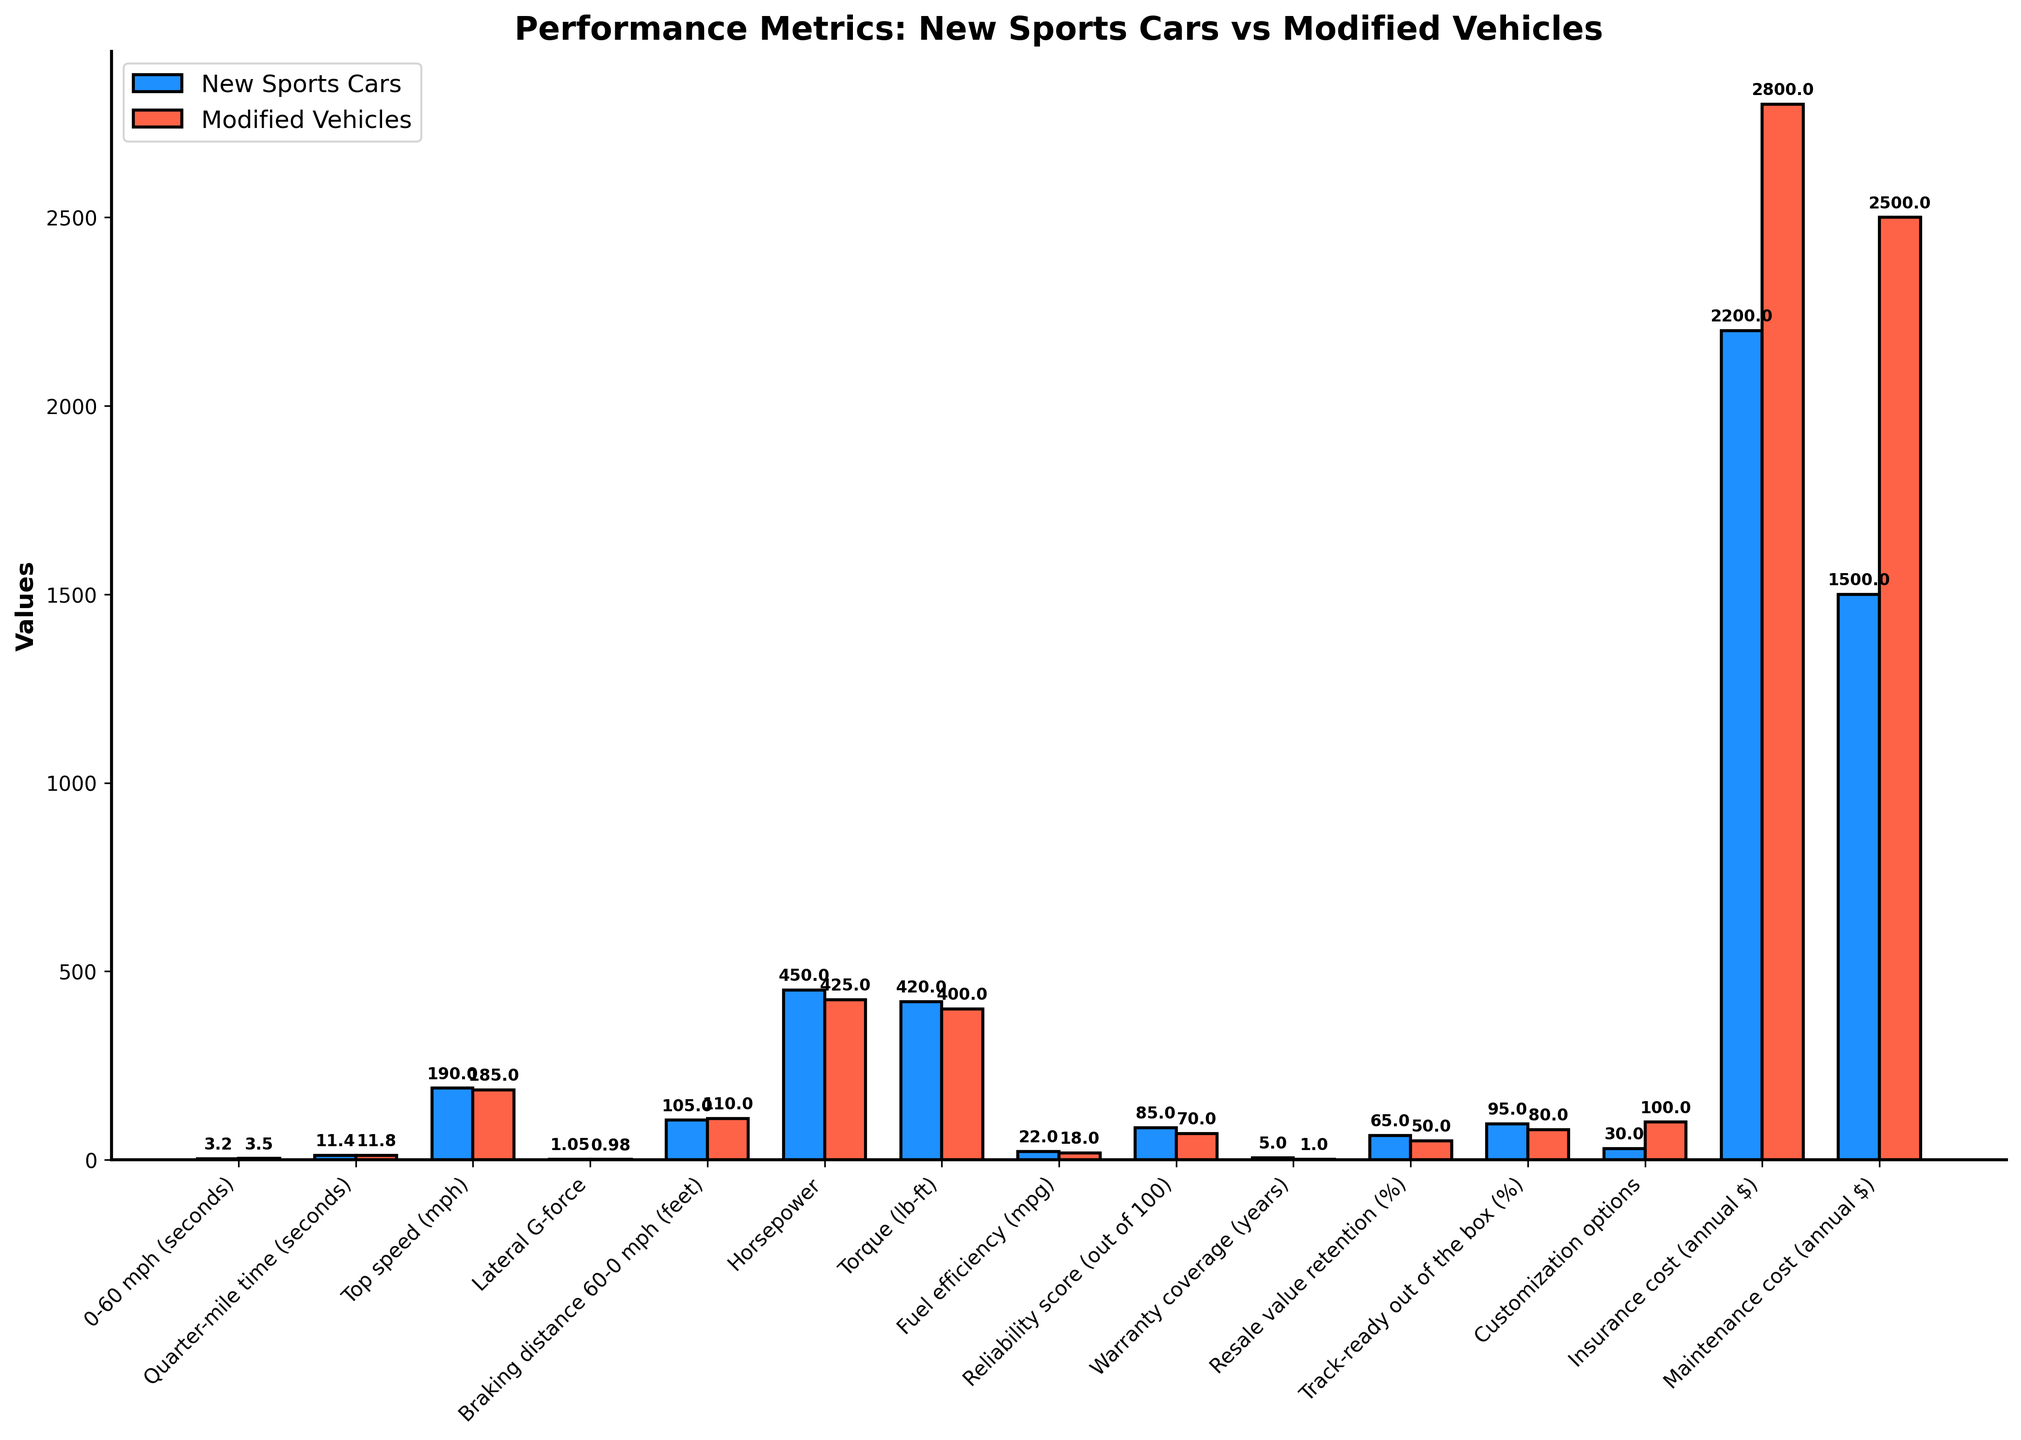What's the difference in 0-60 mph times between new sports cars and modified vehicles? To find the difference in 0-60 mph times, subtract the 0-60 mph time for new sports cars (3.2 seconds) from that of modified vehicles (3.5 seconds). 3.5 - 3.2 = 0.3 seconds
Answer: 0.3 seconds Which category has the largest numerical difference in favor of new sports cars? Compare the numerical differences between new sports cars and modified vehicles across all categories. The largest difference is in the warranty coverage, where new sports cars have a 4-year advantage (5 - 1 = 4).
Answer: Warranty coverage How does the horsepower of new sports cars compare to modified vehicles? Refer to the heights of the bars for horsepower. New sports cars have a horsepower of 450, and modified vehicles have 425 horsepower. Since 450 is greater than 425, new sports cars have higher horsepower.
Answer: New sports cars have higher horsepower What is the visual color difference used to represent new sports cars and modified vehicles? Observe the bar colors: new sports cars are represented by blue bars, while modified vehicles are represented by red bars.
Answer: Blue for new sports cars, Red for modified vehicles What is the average top speed of new sports cars and modified vehicles? Calculate the average of the top speeds. The top speed for new sports cars is 190 mph, and for modified vehicles, it is 185 mph. (190 + 185) / 2 = 187.5 mph
Answer: 187.5 mph Which vehicle type has a better fuel efficiency, and by how much? Compare the fuel efficiency values. New sports cars have 22 mpg, and modified vehicles have 18 mpg. The difference is 22 - 18.
Answer: New sports cars, by 4 mpg In terms of lateral G-force, which vehicle type performs better and by what margin? Check the lateral G-force values. New sports cars have a G-force of 1.05, while modified vehicles have 0.98. The margin is 1.05 - 0.98.
Answer: New sports cars, by 0.07 Calculate the combined annual cost of insurance and maintenance for both types of vehicles. Which is lower? Sum the annual costs for insurance and maintenance for both vehicles. New sports cars: 2200 + 1500 = 3700, modified vehicles: 2800 + 2500 = 5300. New sports cars have a lower combined cost.
Answer: New sports cars How does the reliability score of new sports cars compare to modified vehicles? Compare the reliability scores. New sports cars have a score of 85 out of 100, while modified vehicles have a score of 70 out of 100. Since 85 > 70, new sports cars have a higher reliability score.
Answer: New sports cars have a higher reliability score Which vehicle type is more track-ready out of the box and by what percentage? Check the track-ready percentages. New sports cars are 95% track-ready compared to 80% for modified vehicles. The difference is 95 - 80 = 15%.
Answer: New sports cars, by 15% 